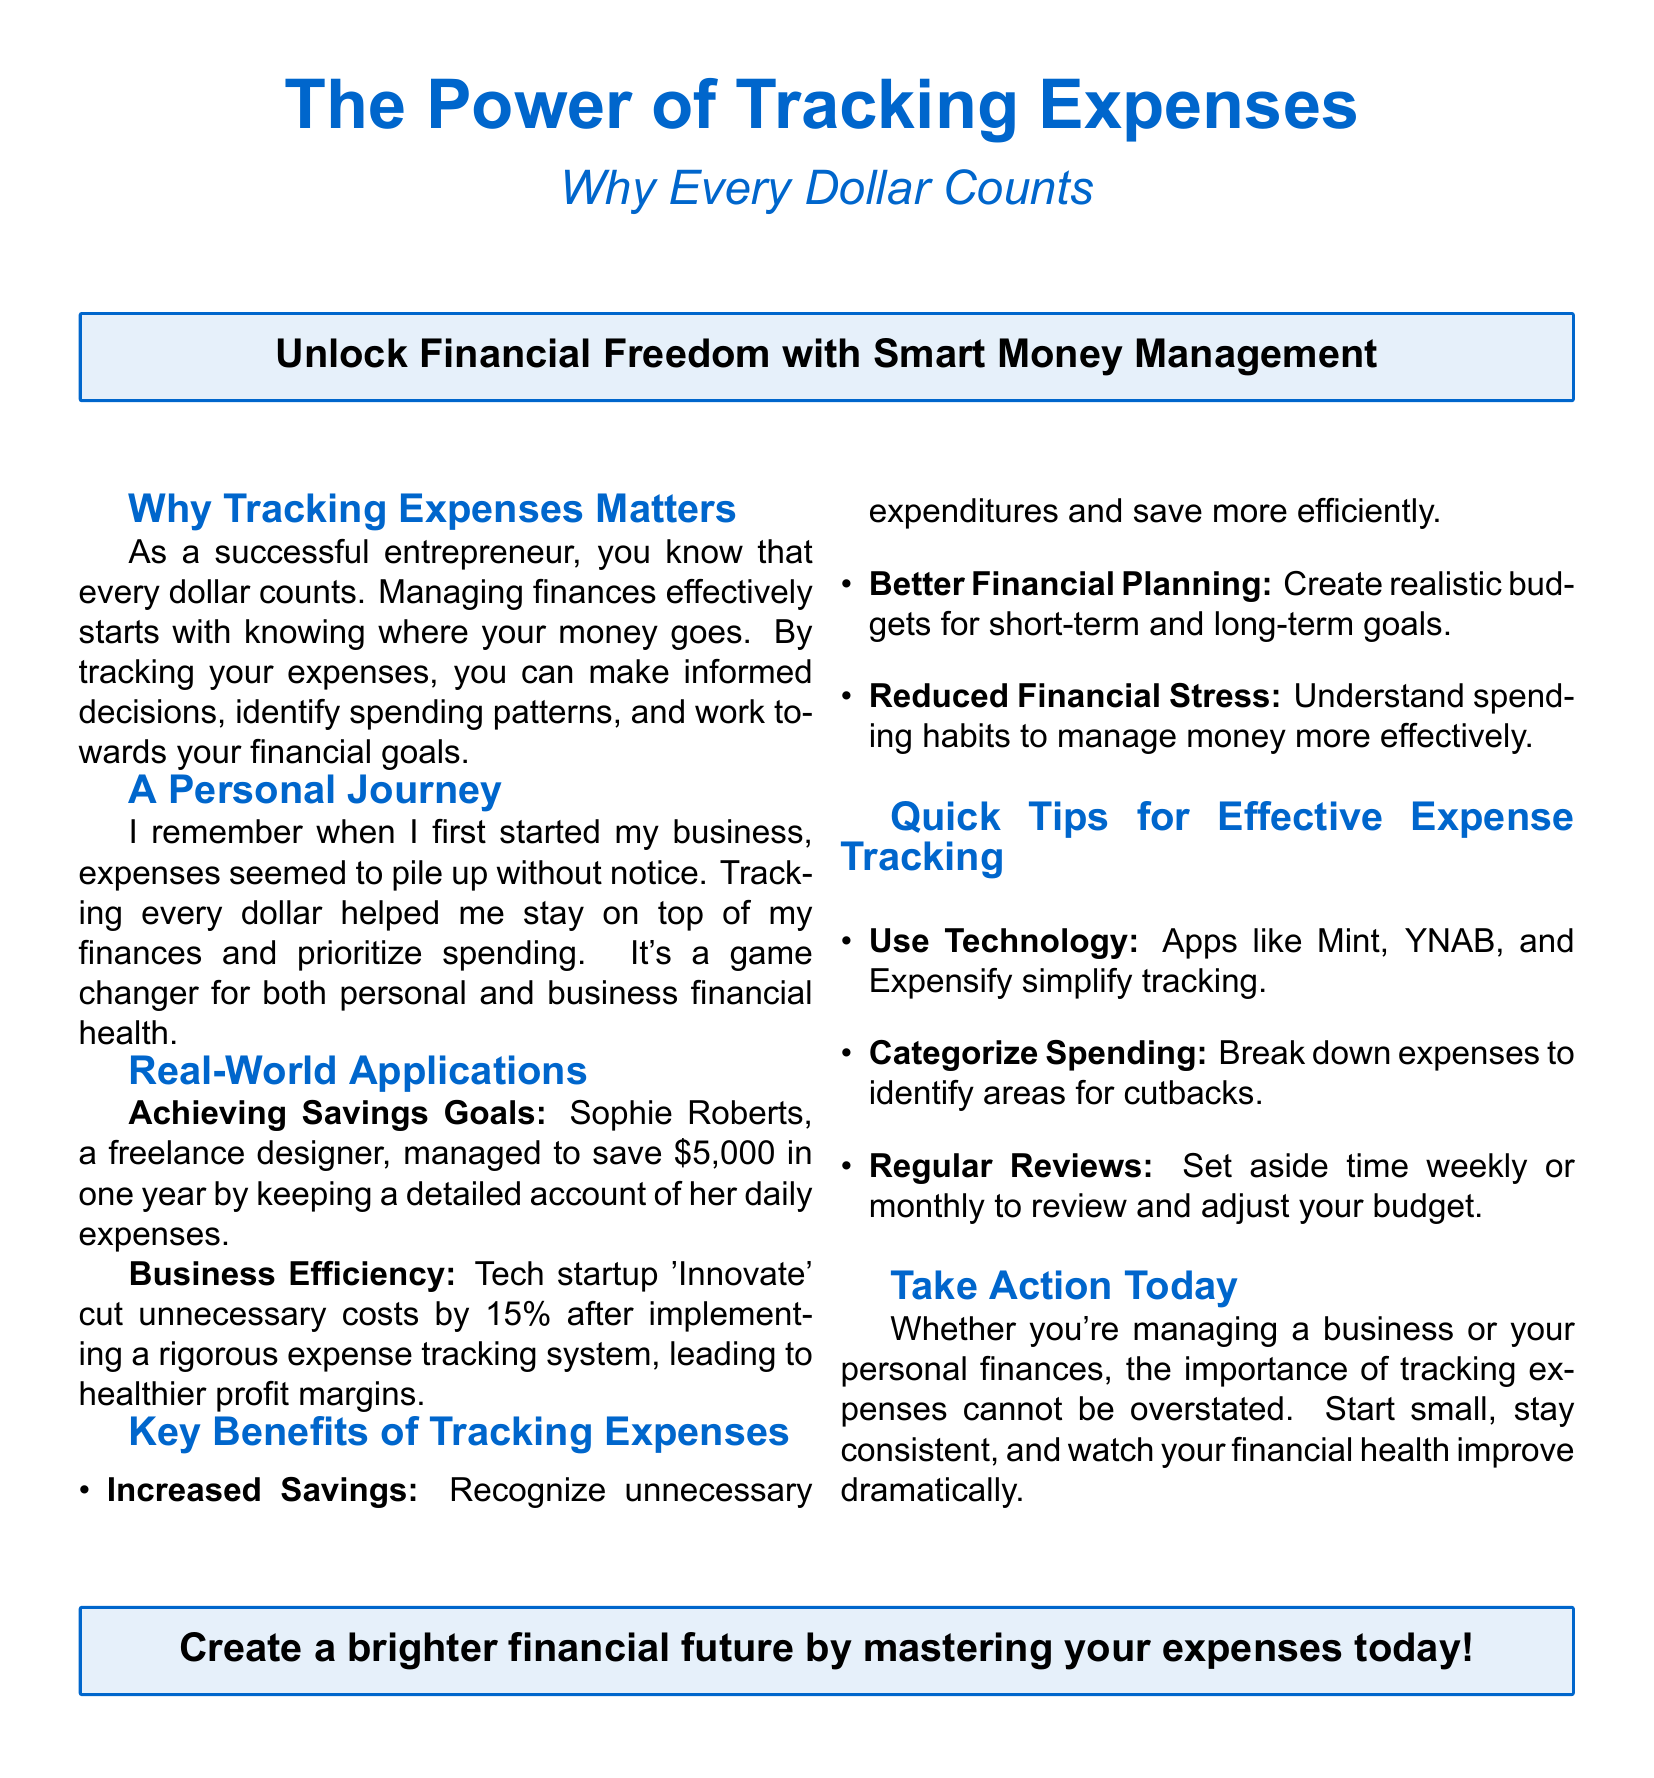What is the title of the flyer? The title of the flyer is prominently displayed at the top.
Answer: The Power of Tracking Expenses Who is mentioned as a successful freelance designer in the document? The document mentions an individual who achieved savings through expense tracking.
Answer: Sophie Roberts What percentage of costs did the startup 'Innovate' cut? This statistic reflects the effectiveness of their expense tracking system.
Answer: 15% What is the first key benefit of tracking expenses listed? It outlines the practical advantages of managing expenses effectively.
Answer: Increased Savings What does the abbreviation YNAB stand for? The flyer lists this tool as an example of an expense tracking app.
Answer: You Need A Budget What is recommended for effective expense tracking regarding technology? This suggests ways to simplify the process of managing expenses.
Answer: Use Technology How much did Sophie Roberts save in a year? The document provides a concrete example of savings achieved through tracking.
Answer: $5,000 What is emphasized as a crucial action to take right away? This call to action urges readers to begin their journey towards financial management.
Answer: Take Action Today 